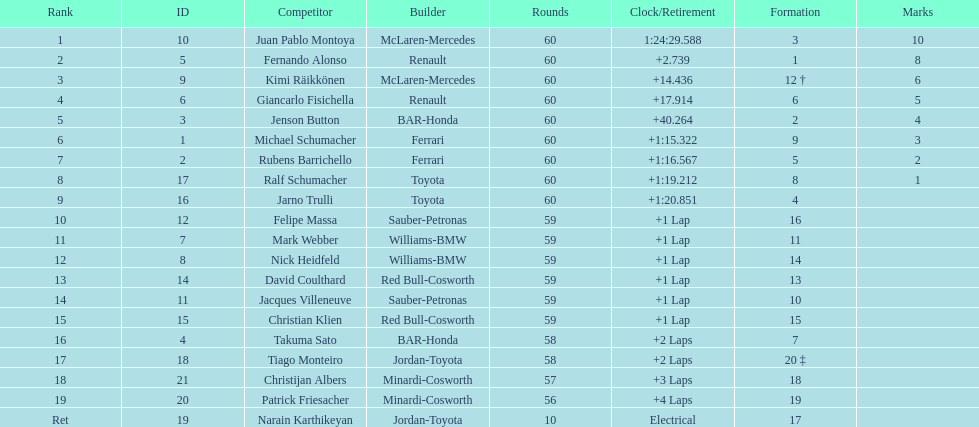What is the number of toyota's on the list? 4. 